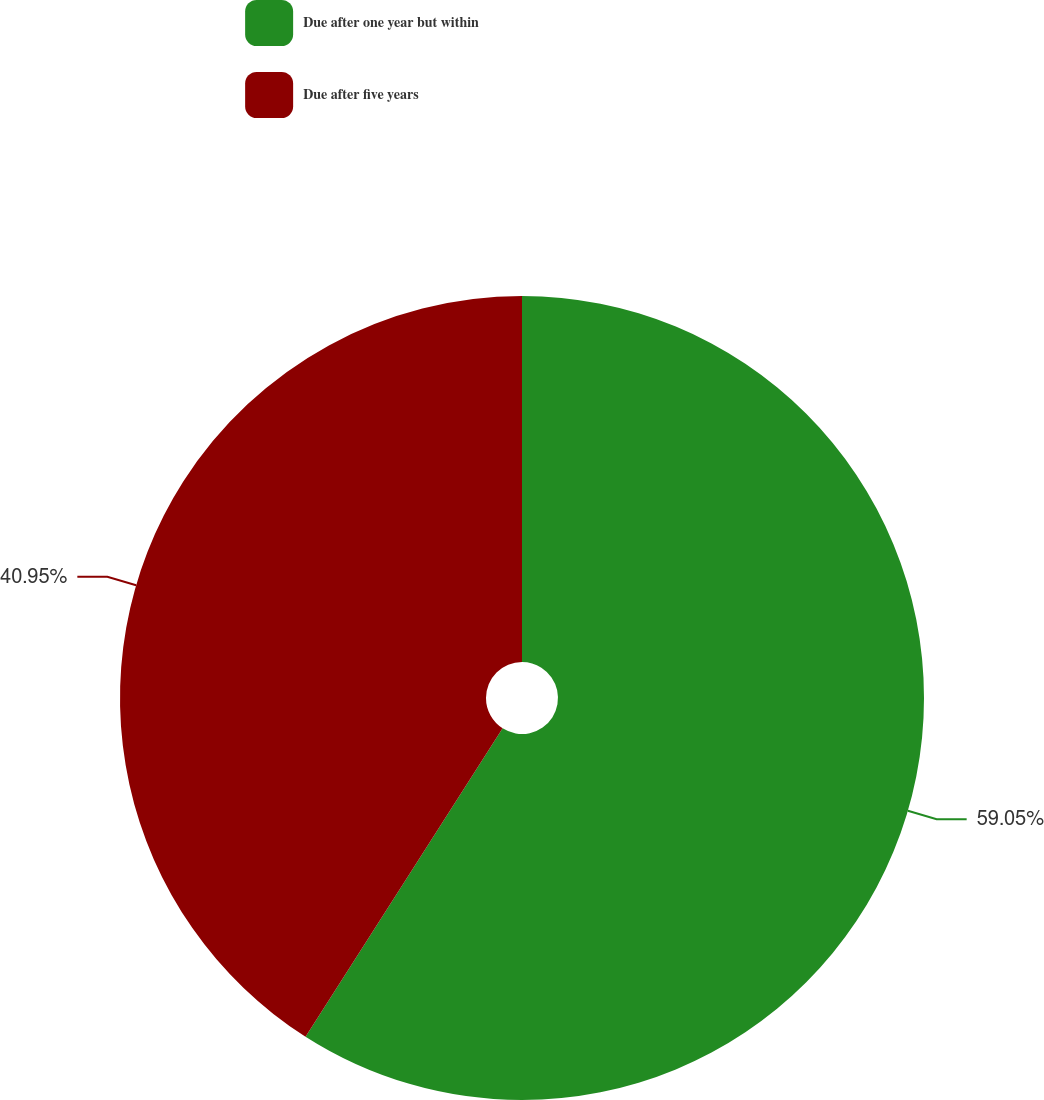Convert chart to OTSL. <chart><loc_0><loc_0><loc_500><loc_500><pie_chart><fcel>Due after one year but within<fcel>Due after five years<nl><fcel>59.05%<fcel>40.95%<nl></chart> 